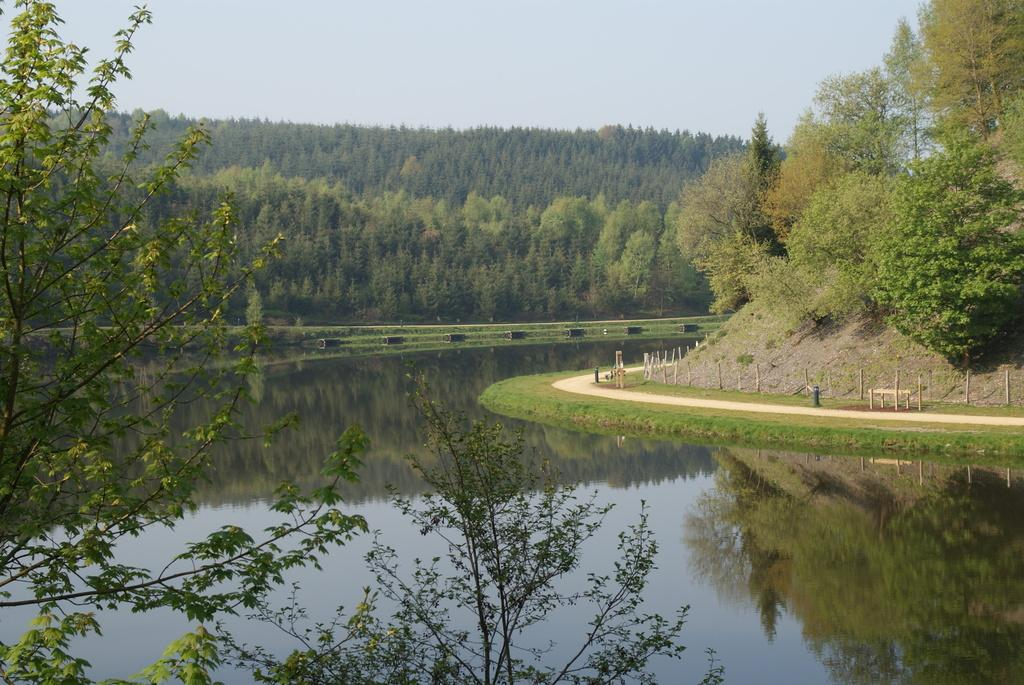What type of natural environment is depicted in the image? There are many trees in the image, suggesting a natural environment. What can be seen at the bottom of the image? There is water visible at the bottom of the image. What is located on the right side of the image? There is fencing, a bench, poles, and other objects on the right side of the image. What is visible at the top of the image? The sky is visible at the top of the image. Can you see the king wearing a crown in the image? There is no king or crown present in the image. How many thumbs are visible in the image? There are no thumbs visible in the image. 